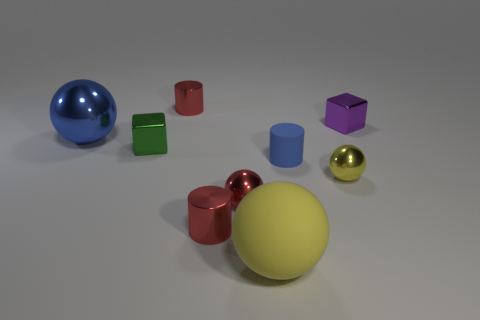Is there any other thing of the same color as the small rubber thing?
Provide a succinct answer. Yes. There is a shiny cylinder that is behind the small green metallic thing; is its color the same as the tiny shiny cylinder that is in front of the green metal block?
Ensure brevity in your answer.  Yes. What is the shape of the tiny thing that is the same color as the big matte sphere?
Give a very brief answer. Sphere. What is the color of the large shiny thing?
Keep it short and to the point. Blue. Is the shape of the red metal thing behind the small blue object the same as the blue thing in front of the green metallic cube?
Offer a terse response. Yes. What is the color of the tiny matte object to the right of the small green cube?
Make the answer very short. Blue. Are there fewer tiny red things on the left side of the big blue metal ball than yellow matte things to the right of the large yellow rubber sphere?
Offer a terse response. No. What number of other objects are there of the same material as the big blue object?
Give a very brief answer. 6. Do the small green object and the small purple block have the same material?
Your answer should be compact. Yes. How many other things are there of the same size as the blue cylinder?
Provide a short and direct response. 6. 